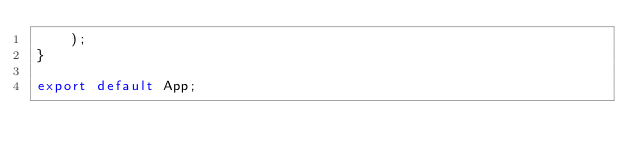Convert code to text. <code><loc_0><loc_0><loc_500><loc_500><_TypeScript_>    );
}

export default App;
</code> 